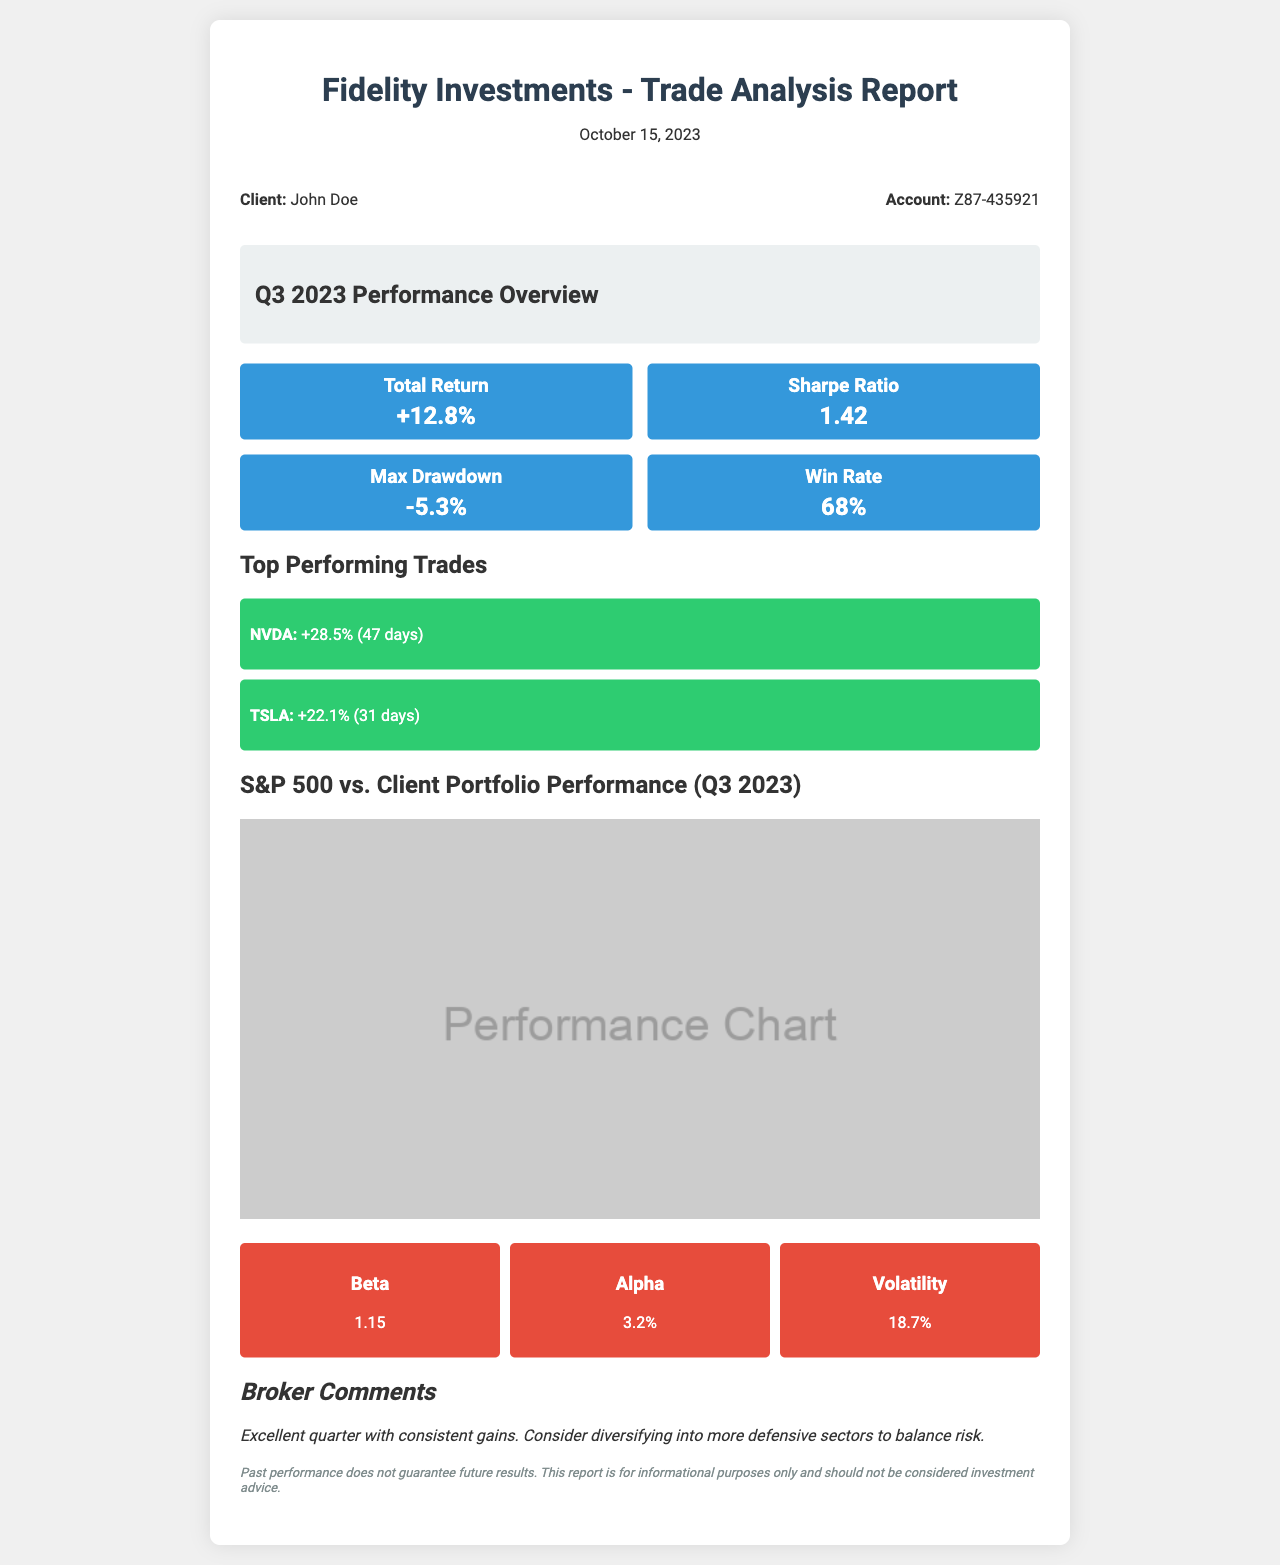What is the total return for Q3 2023? The total return for Q3 2023 is indicated clearly in the metrics section of the report.
Answer: +12.8% What is the Sharpe Ratio? The Sharpe Ratio is a measure of risk-adjusted return, listed under the performance metrics in the document.
Answer: 1.42 What is the maximum drawdown? The maximum drawdown reflects the largest drop from a peak to a trough in the performance metrics section.
Answer: -5.3% How long did the NVDA trade last? The duration of the NVDA trade is specified in the top performing trades section of the report.
Answer: 47 days What percentage increase did TSLA achieve? The percentage increase for TSLA is provided in the context of its performance compared to the entry point in the trades section.
Answer: +22.1% What is the client's name? The client's name is provided in the client info section at the top of the report.
Answer: John Doe What does the broker recommend in the comments? The broker's comment suggests a strategy based on the performance analysis, found in the comments section.
Answer: Consider diversifying into more defensive sectors What is the Beta value? The Beta value represents the systematic risk, as detailed in the risk analysis section of the report.
Answer: 1.15 What is the date of the report? The date is stated at the top of the document under the title.
Answer: October 15, 2023 